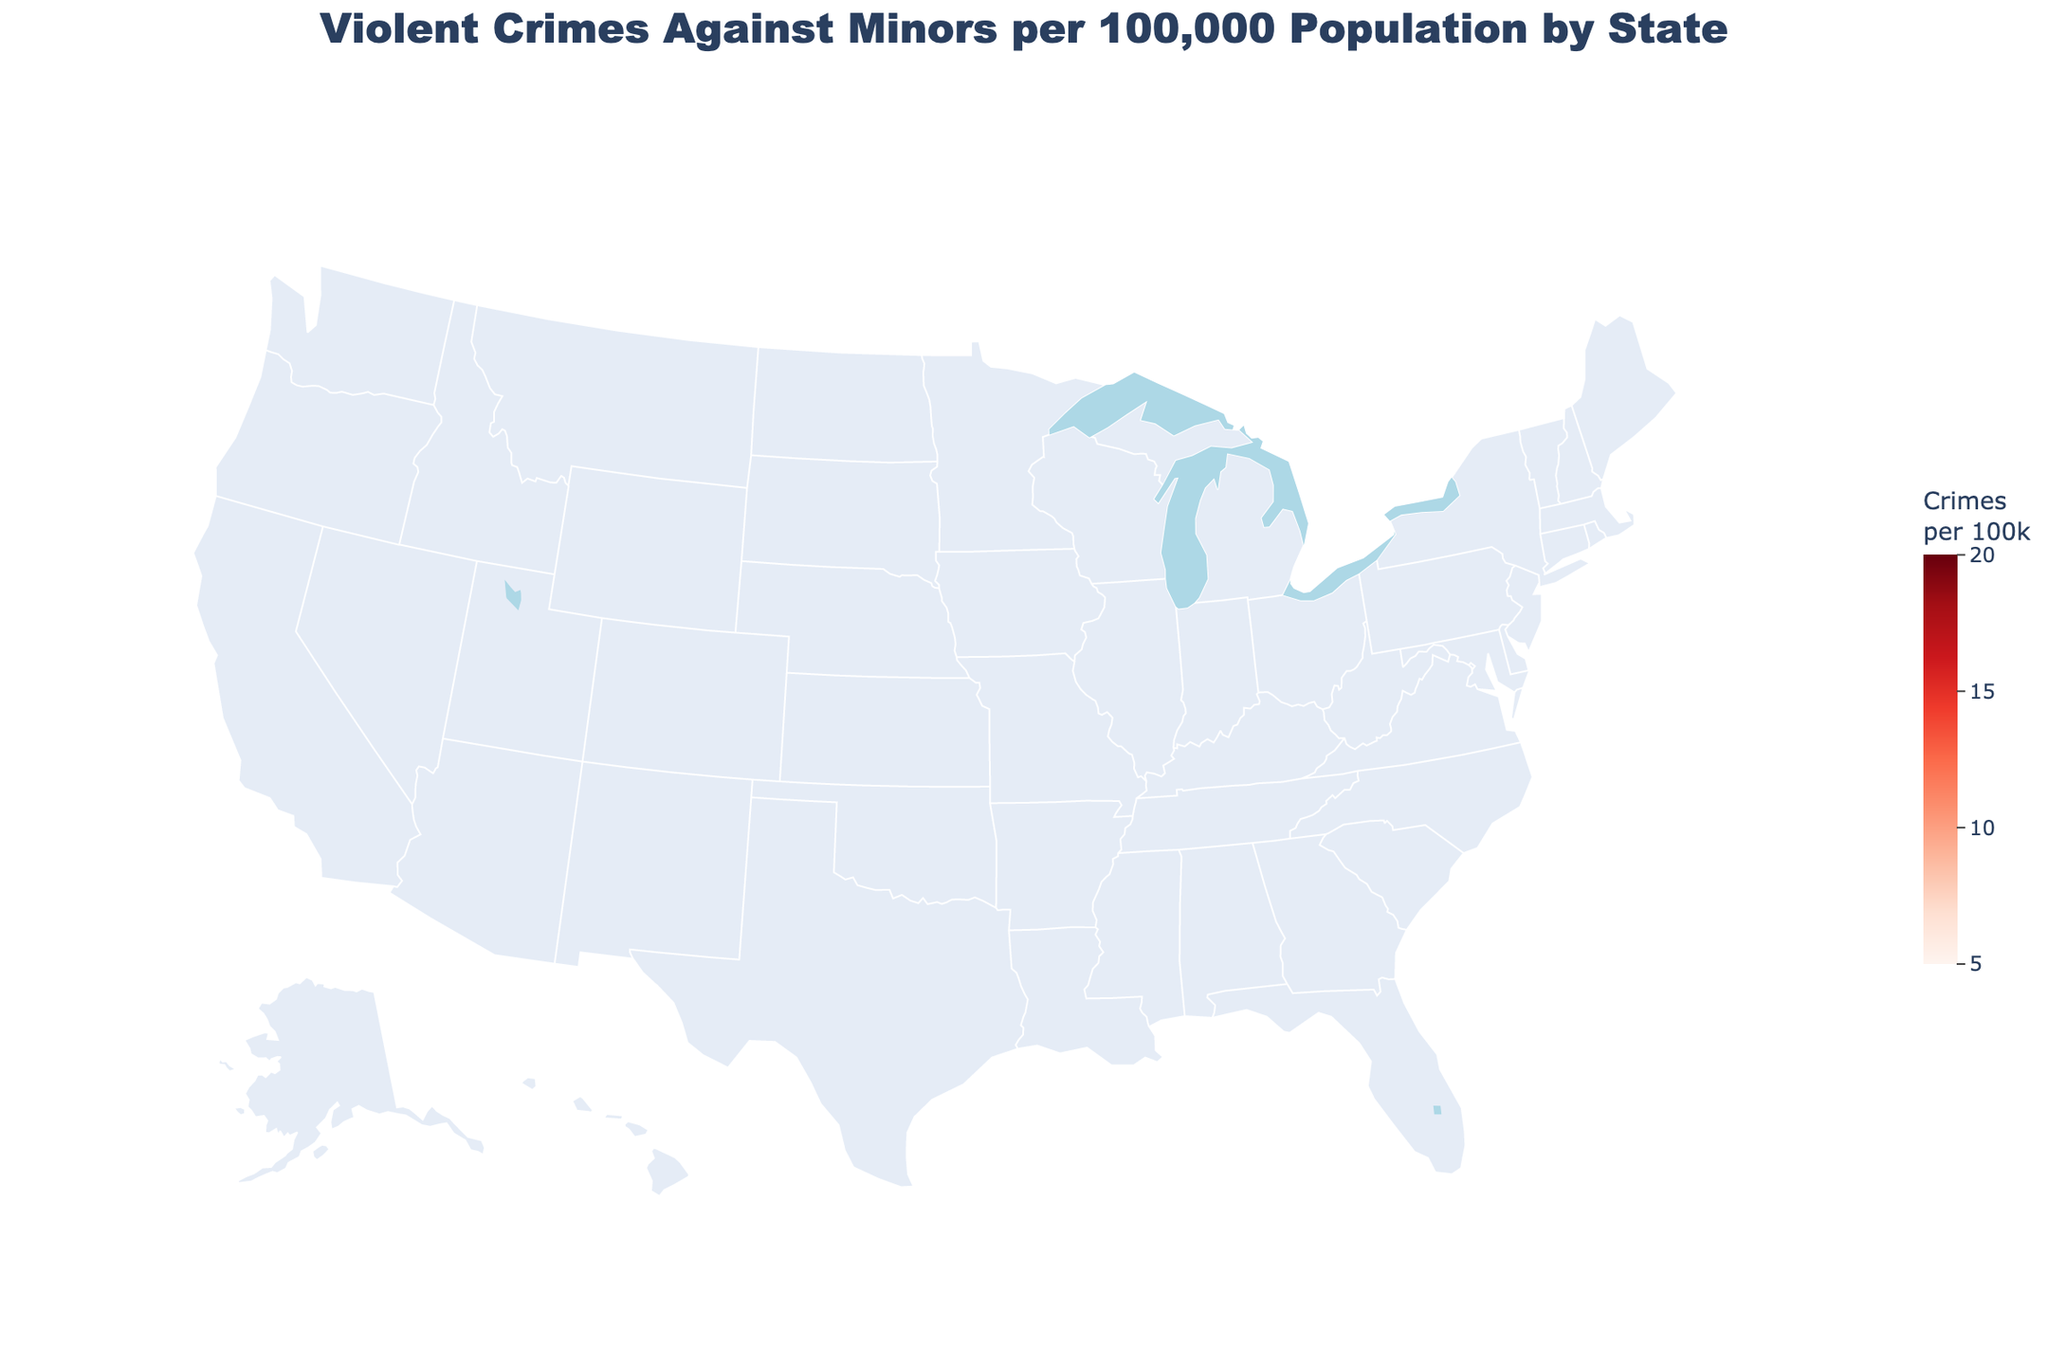How many states have a violent crime rate against minors higher than 15 per 100,000? To determine this, look at the values displayed for each state on the map or in the data hover. Count the states with values greater than 15.
Answer: 10 Which state has the highest rate of violent crimes against minors? Identify the state with the highest numeric value for violent crimes against minors in the figure. Missouri has the highest rate of 19.2 per 100,000.
Answer: Missouri Which state has both a high rate of violent crimes against minors and weak child protection laws? Rank the states by their violent crime rates against minors and child protection laws strength. Tennessee and Missouri have high rates (18.7 and 19.2 respectively) and weak laws (5).
Answer: Tennessee, Missouri What's the difference between the highest and lowest rates of violent crimes against minors among these states? Find the highest value (Missouri, 19.2) and the lowest value (Massachusetts, 7.8) and subtract the lowest from the highest: 19.2 - 7.8 = 11.4
Answer: 11.4 Is there a visual trend between states with stronger child protection laws and the rate of violent crimes against minors? Examine the color gradient (indicating crime rate) in relation to the hover data showing child protection laws strength. States with stronger laws like Massachusetts and New York tend to have lower crime rates against minors (7.8 and 10.1 respectively).
Answer: Yes Which states have a discrepancy between their general violent crime rates and violent crimes against minors? Compare the hover data for overall violent crime rates and violent crime rates against minors. For example, Arizona has a high overall violent crime rate (455.3) but a moderately high rate against minors (15.9).
Answer: Arizona Do states with lower overall violent crime rates have lower violent crimes against minors too? Check the figure for states where both overall violent crime and minor-specific violent crime rates are low. States like New Jersey with low overall (206.9) and minor-specific (8.9) rates show this trend.
Answer: Generally, yes Which states have similar rates of violent crimes against minors and what are their child protection law strengths? Find states with nearly identical rates of violent crimes against minors and check their laws. For example, California (15.2) and Texas (14.8) have comparable rates with child protection law strengths of 8 and 7 respectively.
Answer: California (8), Texas (7) How does the overall violent crime rate compare to the violent crime rate against minors in Florida? Refer to Florida's respective values on the chart. The violent crime rate against minors is 16.5, while the overall violent crime rate is 384.9.
Answer: Higher overall Which state at the lower end of the violent crime rate spectrum against minors also has strong child protection laws? Identify states with low violent crime rates against minors and check their child protection law strengths. Massachusetts has a low rate (7.8) and strong child protection laws (9).
Answer: Massachusetts 